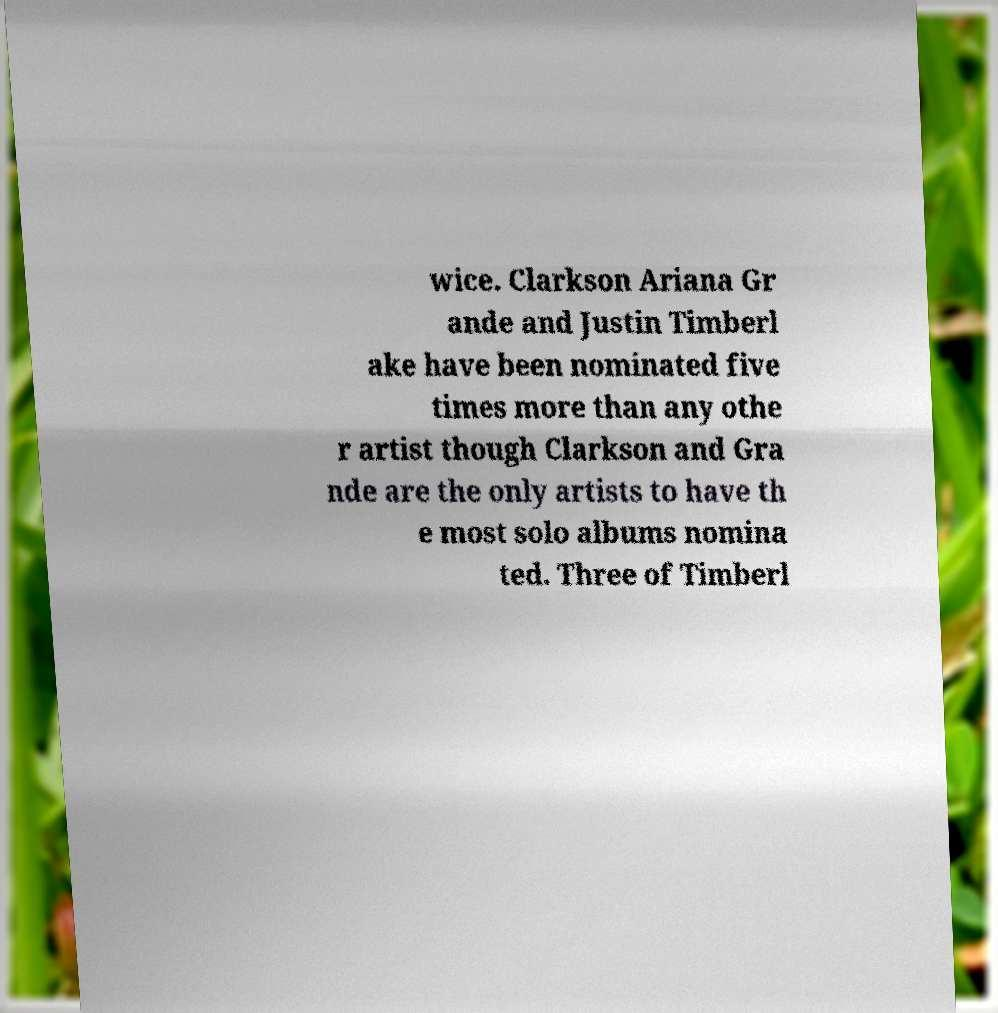There's text embedded in this image that I need extracted. Can you transcribe it verbatim? wice. Clarkson Ariana Gr ande and Justin Timberl ake have been nominated five times more than any othe r artist though Clarkson and Gra nde are the only artists to have th e most solo albums nomina ted. Three of Timberl 